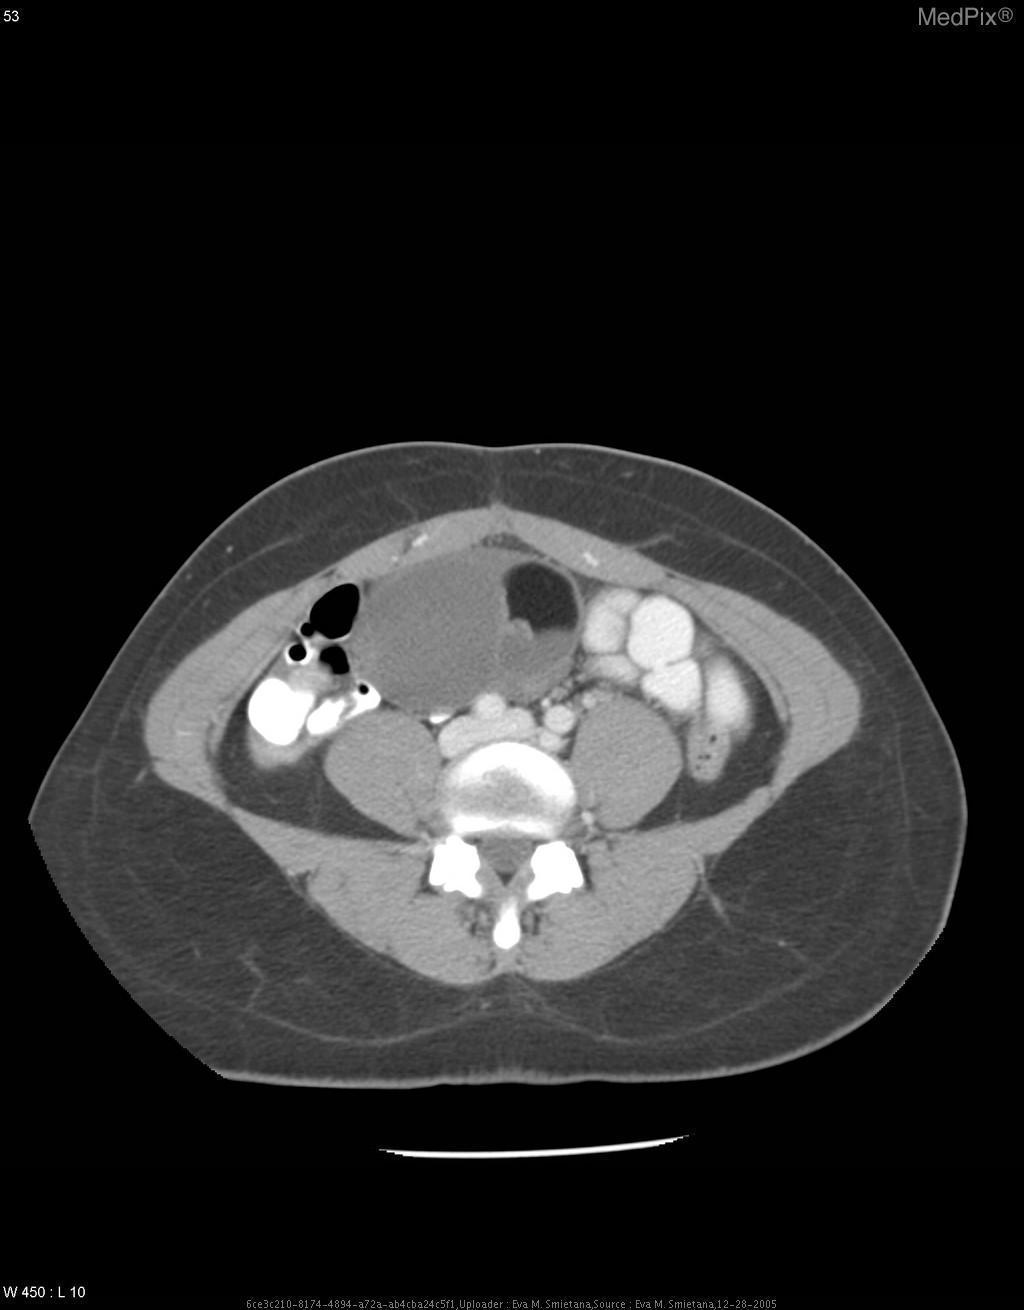Is there fat in these masses?
Write a very short answer. Yes. Is the mass cystic?
Answer briefly. Yes. Would you describe the mass as cystic?
Give a very brief answer. Yes. Do the masses contain calcification?
Concise answer only. Yes. Is there calcification
Answer briefly. Yes. Can you appreciate a mass in this image?
Answer briefly. Yes. Is there a mass demonstrated?
Be succinct. Yes. 